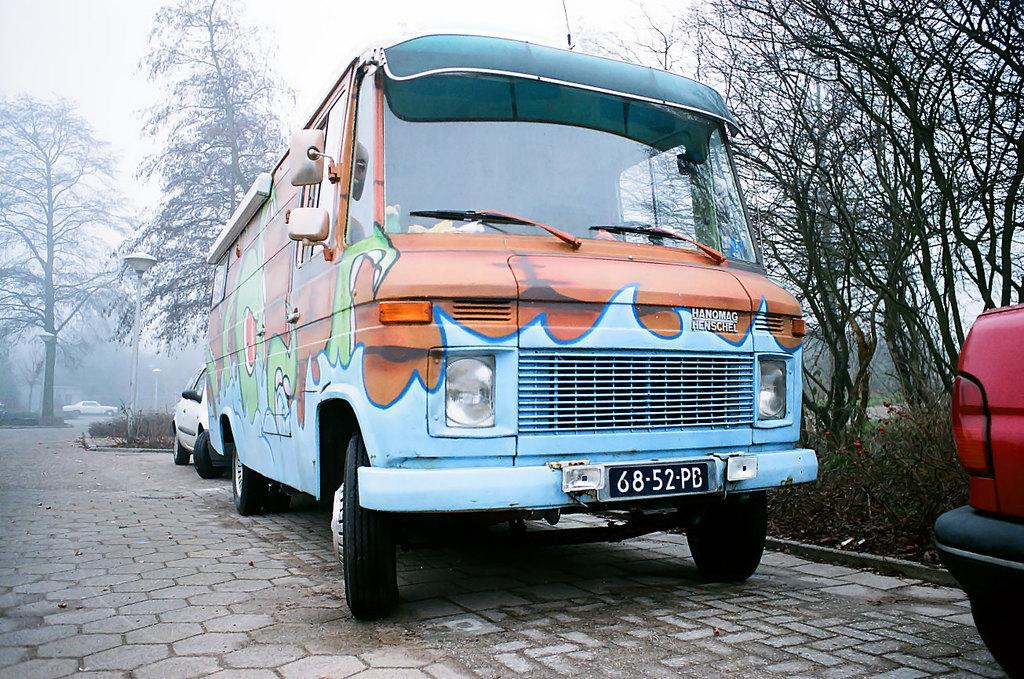<image>
Present a compact description of the photo's key features. A Hanomag Henschel van is painted in bright colors. 